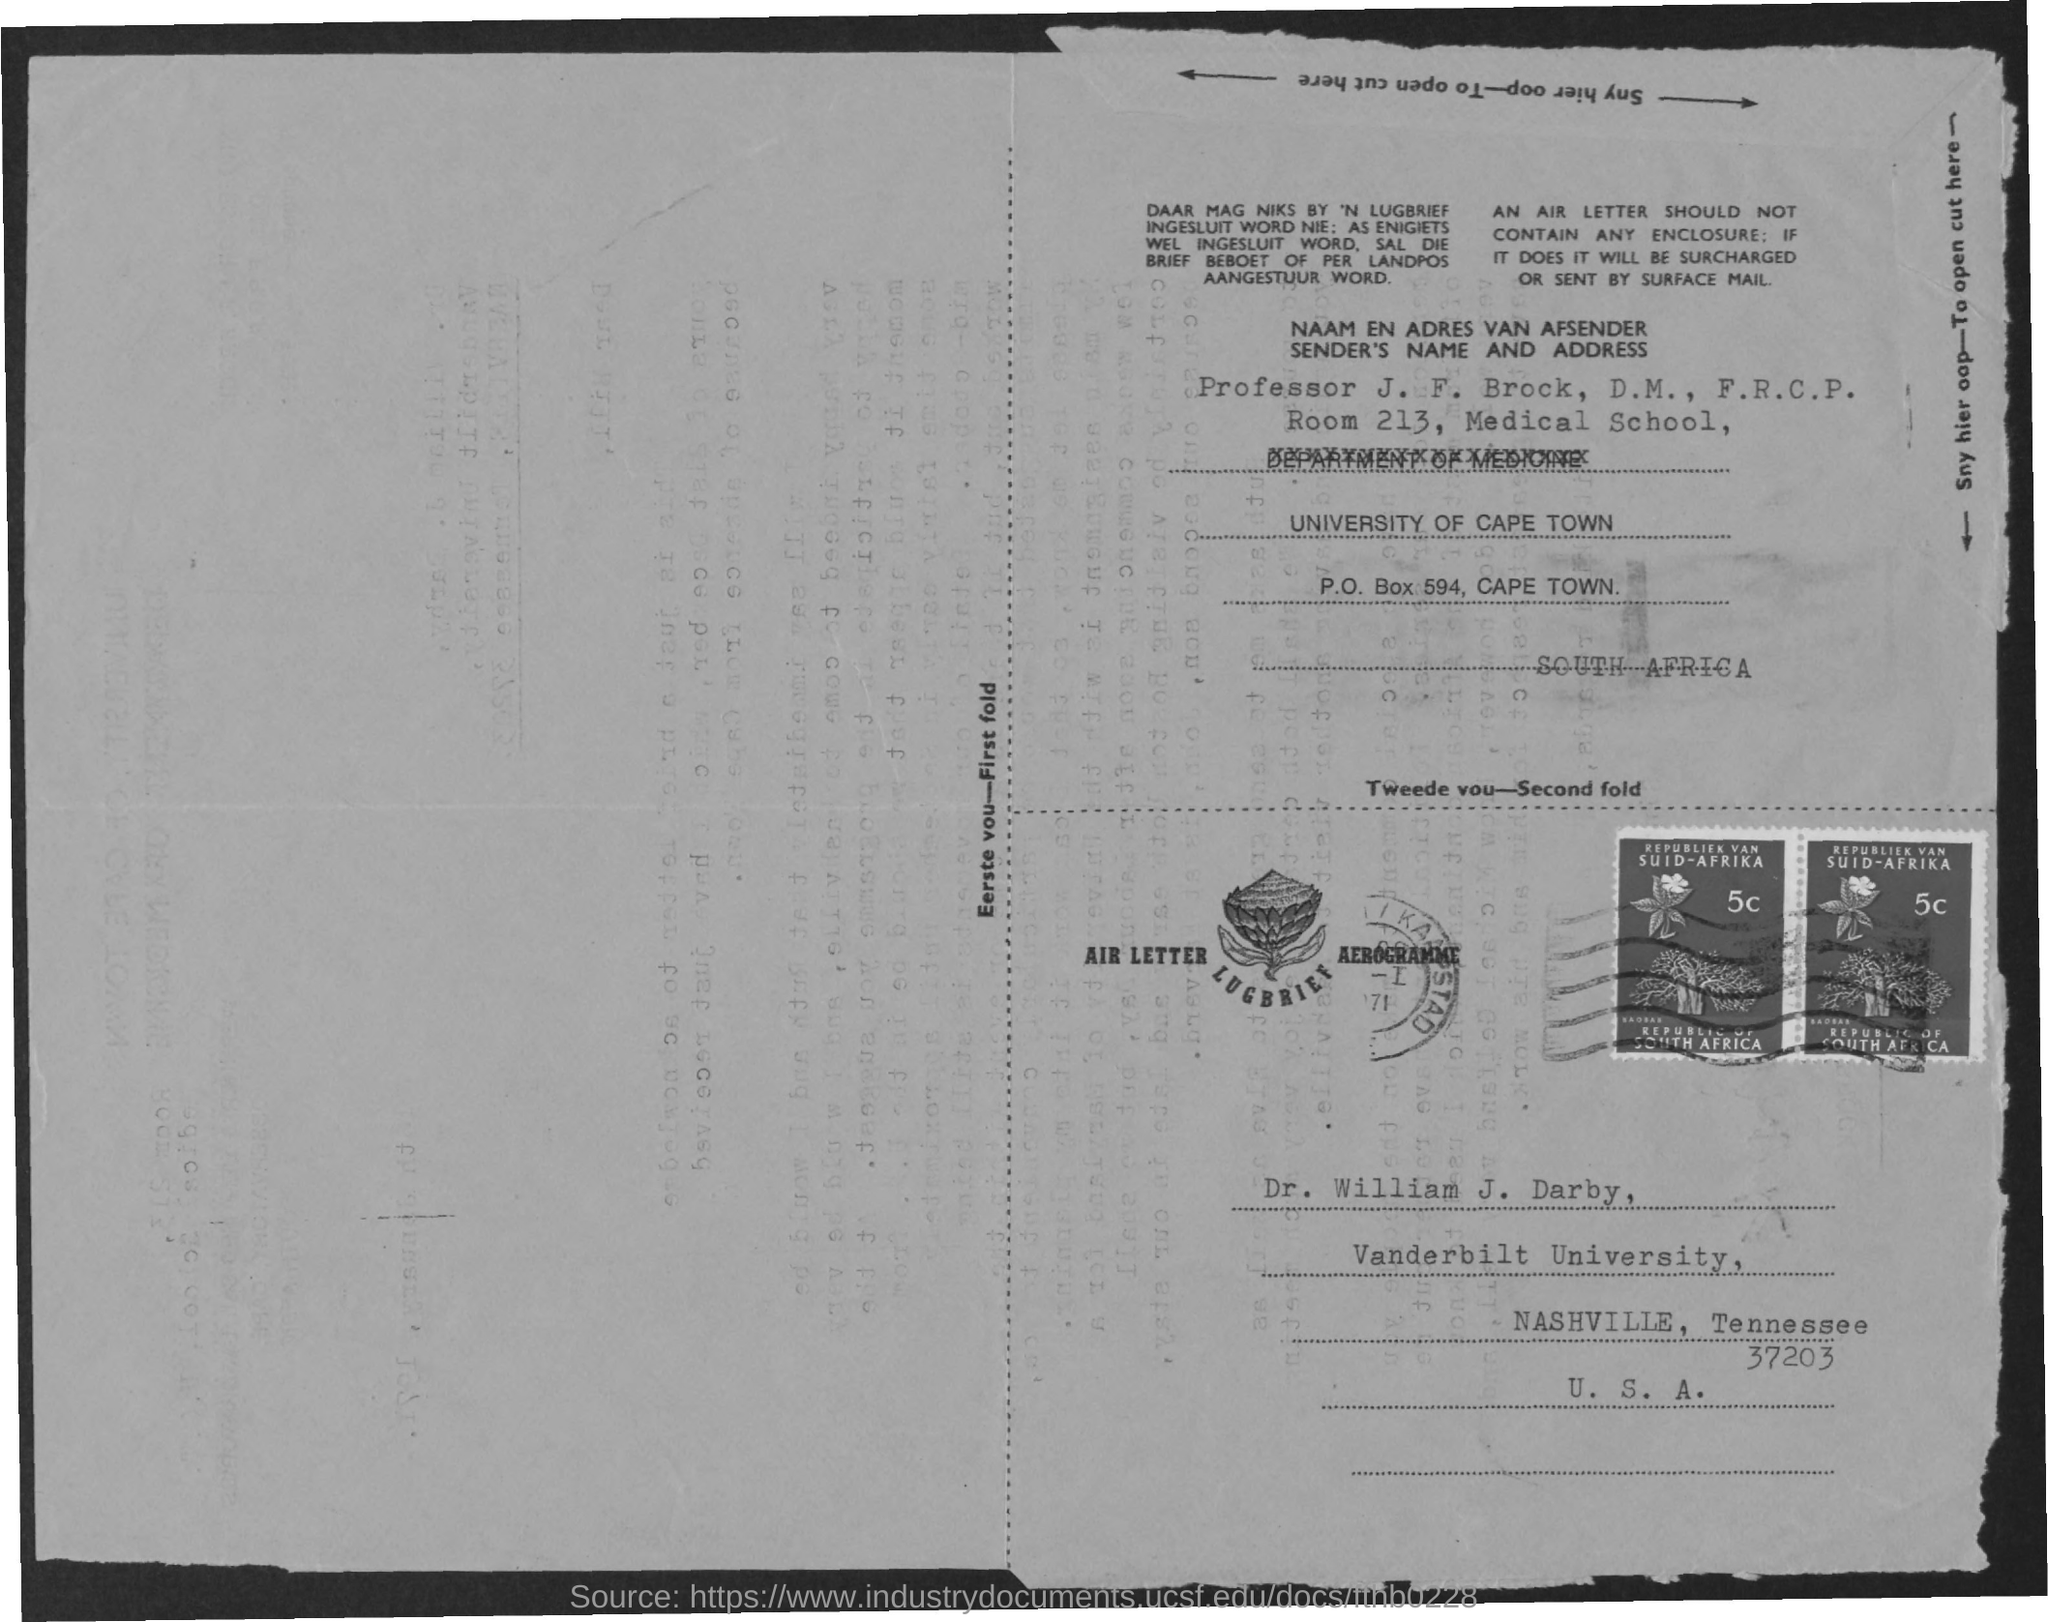To Whom is this letter addressed to?
Keep it short and to the point. Dr. William J. Darby. Which University is Dr. William J. Darby from?
Give a very brief answer. Vanderbilt University. 